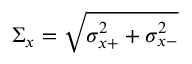Convert formula to latex. <formula><loc_0><loc_0><loc_500><loc_500>\Sigma _ { x } = \sqrt { \sigma _ { x + } ^ { 2 } + \sigma _ { x - } ^ { 2 } }</formula> 